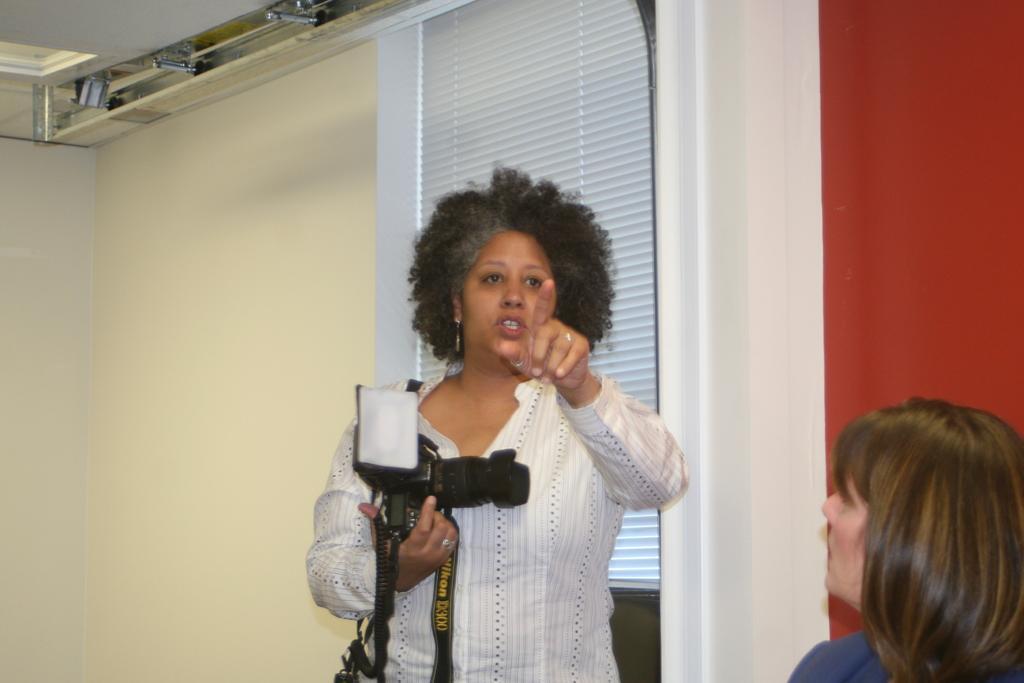Describe this image in one or two sentences. There is a woman standing in the middle and she is holding a camera and she is pointing a finger, In the right side there is a woman sitting, In the background there is a multi color wall. 